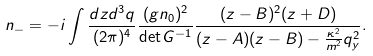Convert formula to latex. <formula><loc_0><loc_0><loc_500><loc_500>n _ { - } & = - i \int \frac { d z d ^ { 3 } q } { ( 2 \pi ) ^ { 4 } } \frac { ( g n _ { 0 } ) ^ { 2 } } { \det G ^ { - 1 } } \frac { ( z - B ) ^ { 2 } ( z + D ) } { ( z - A ) ( z - B ) - \frac { \kappa ^ { 2 } } { m ^ { 2 } } q _ { y } ^ { 2 } } . \\</formula> 